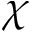Convert formula to latex. <formula><loc_0><loc_0><loc_500><loc_500>\chi</formula> 